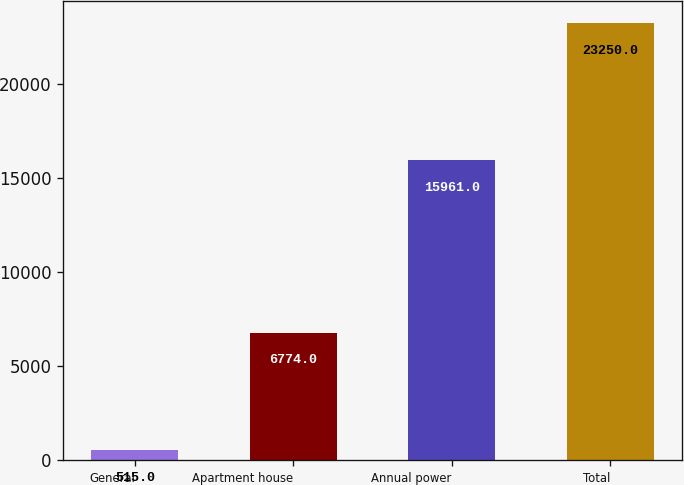Convert chart to OTSL. <chart><loc_0><loc_0><loc_500><loc_500><bar_chart><fcel>General<fcel>Apartment house<fcel>Annual power<fcel>Total<nl><fcel>515<fcel>6774<fcel>15961<fcel>23250<nl></chart> 